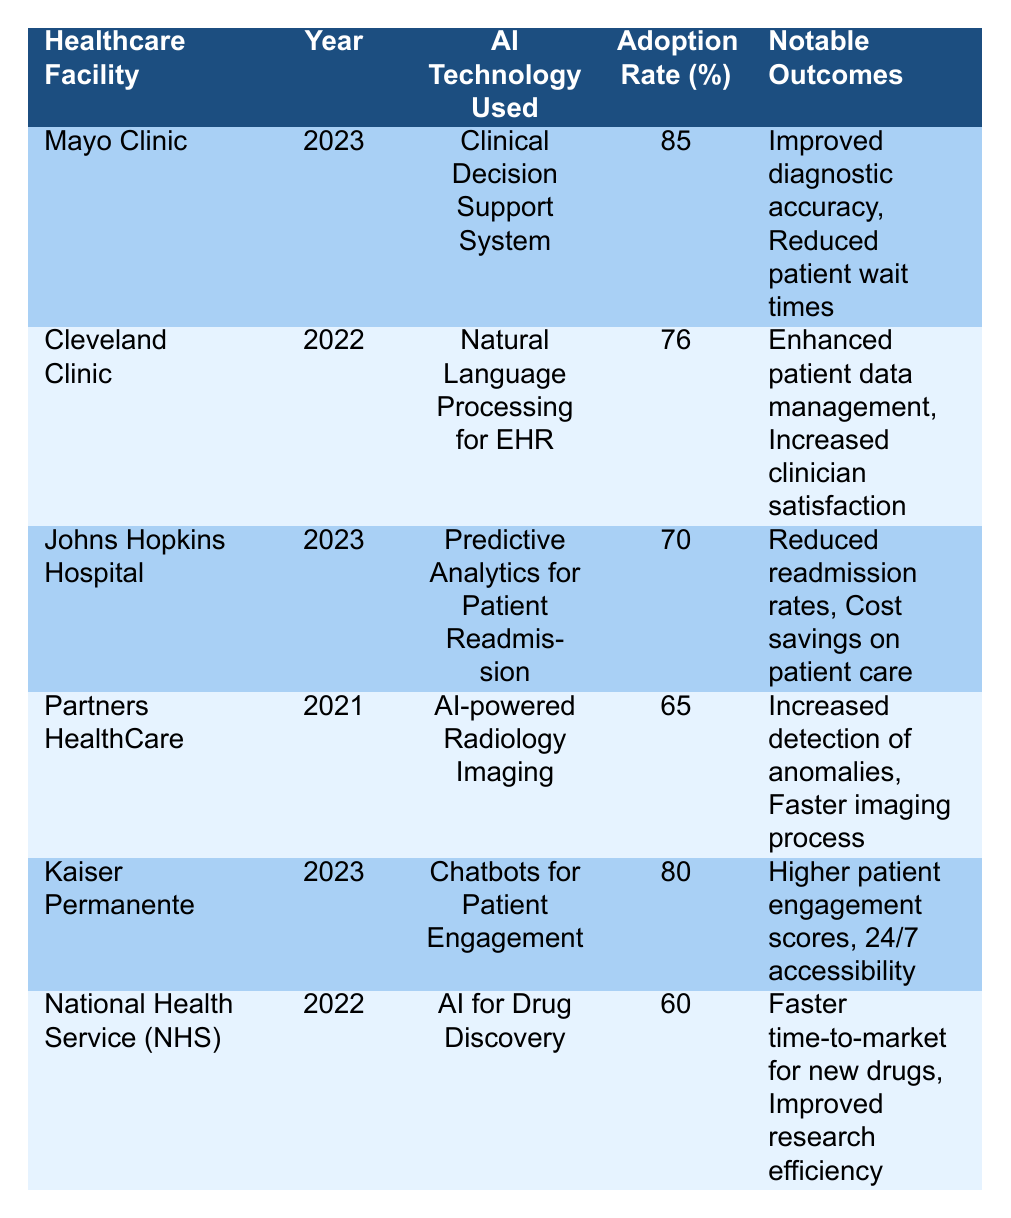What is the adoption rate of AI technology at Mayo Clinic in 2023? The table lists the adoption rate for each healthcare facility. For Mayo Clinic in 2023, the adoption rate is specified directly in the corresponding row.
Answer: 85 Which healthcare facility reported using Natural Language Processing in 2022? Looking at the table, the Cleveland Clinic is the only facility that mentions Natural Language Processing for EHR in the year 2022.
Answer: Cleveland Clinic What were the notable outcomes for Kaiser Permanente's AI technology used in 2023? The table indicates that Kaiser Permanente employed Chatbots for Patient Engagement in 2023 and lists the notable outcomes as higher patient engagement scores and 24/7 accessibility.
Answer: Higher patient engagement scores, 24/7 accessibility What is the average adoption rate of AI technology across all facilities in 2023? The adoption rates for 2023 from the table are 85 (Mayo Clinic), 70 (Johns Hopkins Hospital), and 80 (Kaiser Permanente). To find the average, we sum these values (85 + 70 + 80 = 235) and then divide by the number of facilities (3). Therefore, the average is 235 / 3 = 78.33.
Answer: 78.33 Is the adoption rate of AI technology at National Health Service higher than at Partners HealthCare? The adoption rate for National Health Service is 60, and for Partners HealthCare, it is 65. Since 60 is less than 65, the statement is false.
Answer: No Which AI technology was adopted by Johns Hopkins Hospital in 2023, and what was its adoption rate? Referring to the table, Johns Hopkins Hospital used Predictive Analytics for Patient Readmission, with an adoption rate of 70.
Answer: Predictive Analytics for Patient Readmission, 70 Which facility had the lowest AI adoption rate and what was the technology used? The lowest adoption rate from the table is for the National Health Service at 60, which used AI for Drug Discovery.
Answer: National Health Service, AI for Drug Discovery Did any facility report an adoption rate of 76% or higher? By examining the table, Mayo Clinic (85%) and Kaiser Permanente (80%) fall into this category. Thus, the answer is true.
Answer: Yes What are the notable outcomes stated for the Cleveland Clinic's AI technology in 2022? The table specifies the outcomes for Cleveland Clinic’s use of Natural Language Processing as enhanced patient data management and increased clinician satisfaction.
Answer: Enhanced patient data management, Increased clinician satisfaction 